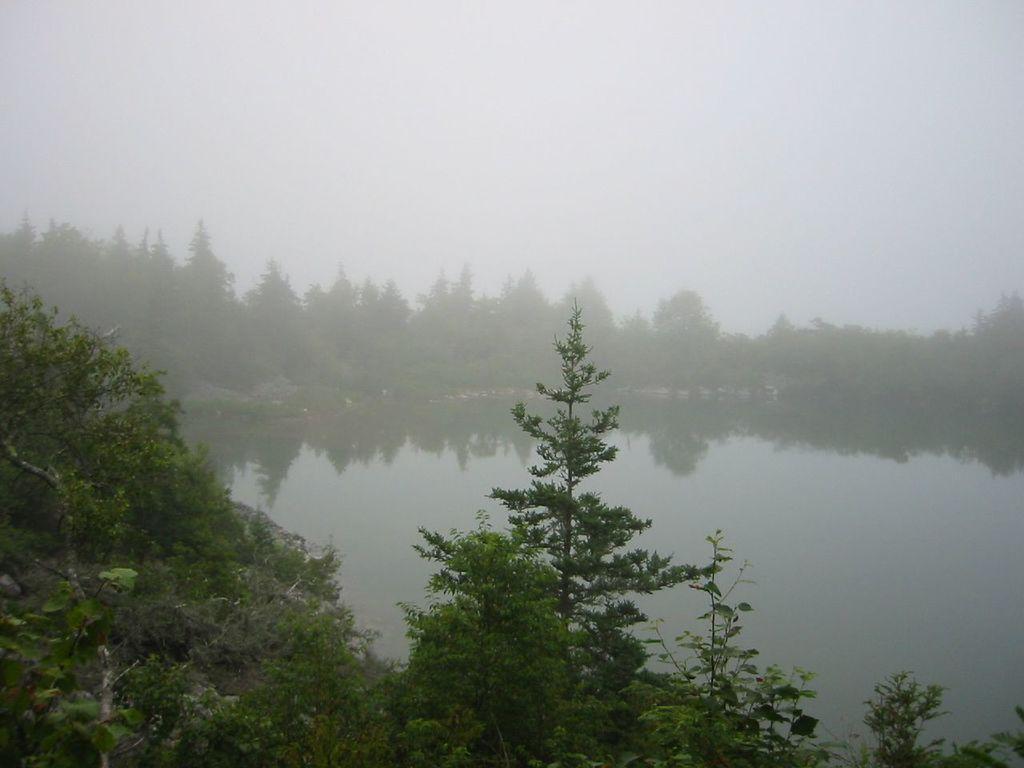Can you describe this image briefly? As we can see in the image there are trees, water and sky. 